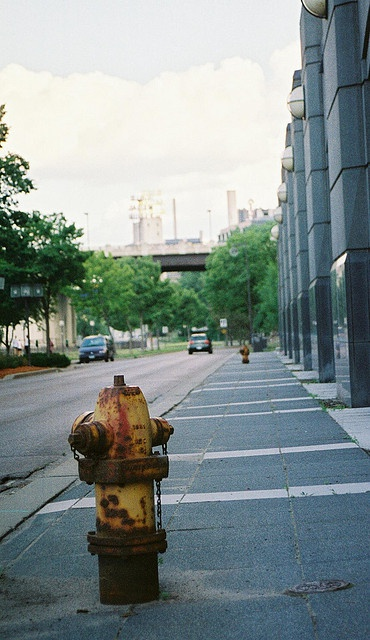Describe the objects in this image and their specific colors. I can see fire hydrant in lightgray, black, maroon, and olive tones, car in lightgray, black, gray, and darkgray tones, car in lightgray, black, darkgray, and gray tones, and fire hydrant in lightgray, black, maroon, gray, and darkgray tones in this image. 